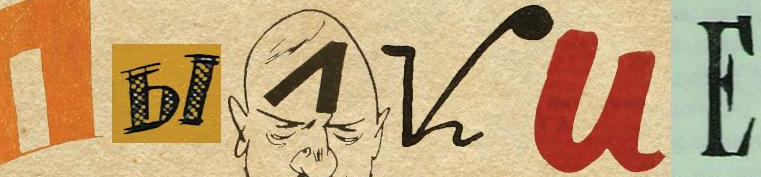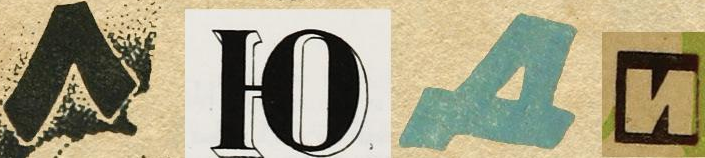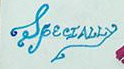Read the text from these images in sequence, separated by a semicolon. I##VUЕ; ####; SpecIALLy 